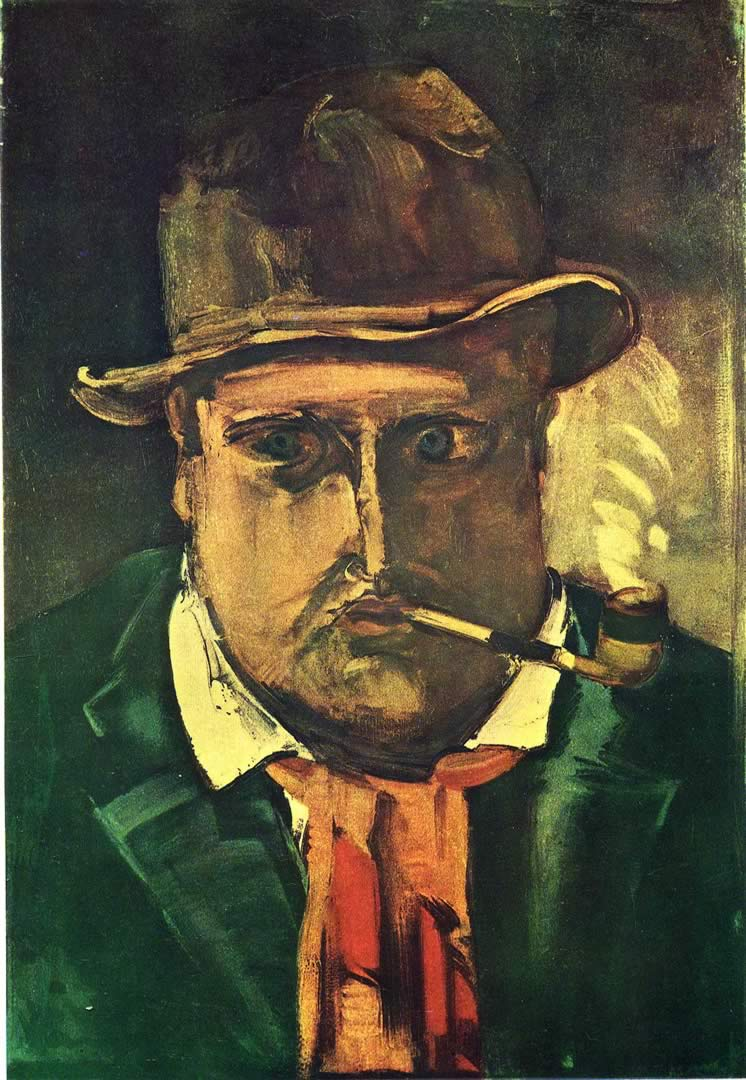Can you discuss the significance of the man's hat and its appearance in this artwork? The hat, with its worn-out look and slightly drooping form, complements the overall theme of weariness or burden. It adds a layer of personal history and perhaps social identity, potentially indicating the man's working-class background or his roles in society. 